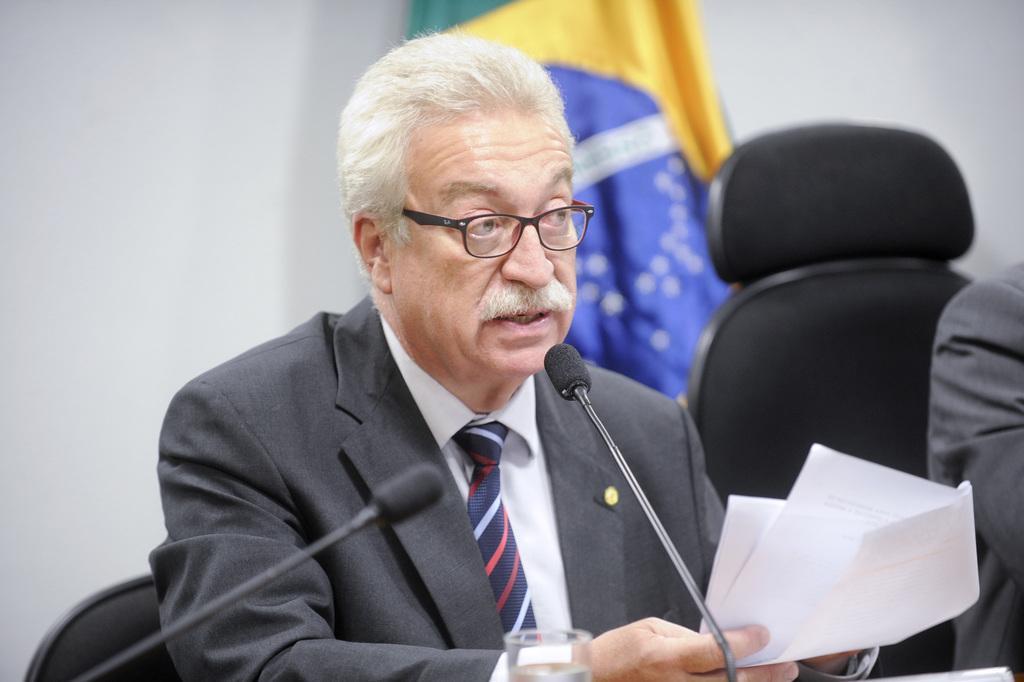In one or two sentences, can you explain what this image depicts? In this image we can see a man sitting on the chair and holding papers in his hands. On the table in front of the man we can see glass tumbler and mics. In the background there are walls and flag. 